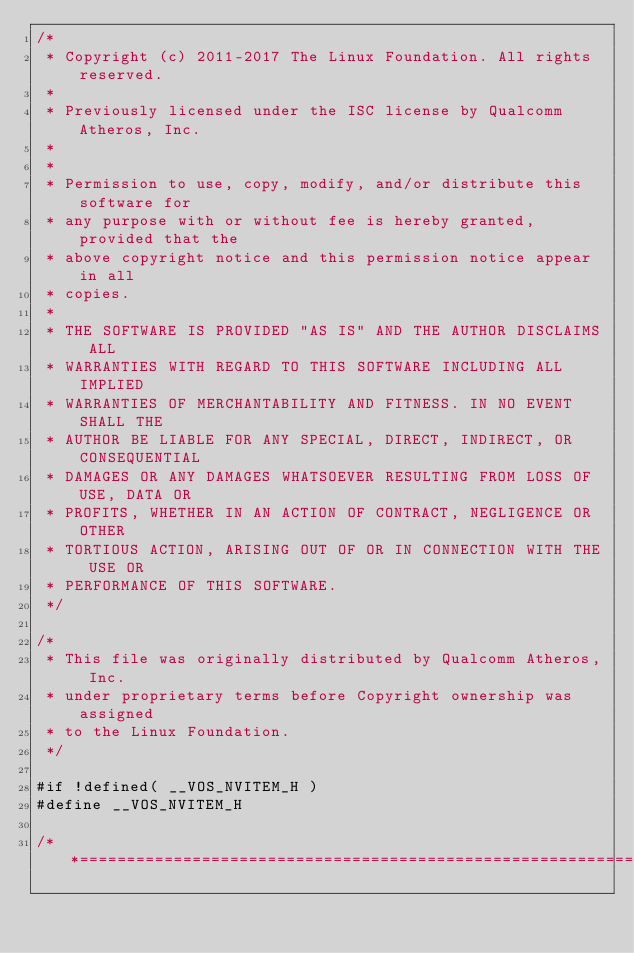<code> <loc_0><loc_0><loc_500><loc_500><_C_>/*
 * Copyright (c) 2011-2017 The Linux Foundation. All rights reserved.
 *
 * Previously licensed under the ISC license by Qualcomm Atheros, Inc.
 *
 *
 * Permission to use, copy, modify, and/or distribute this software for
 * any purpose with or without fee is hereby granted, provided that the
 * above copyright notice and this permission notice appear in all
 * copies.
 *
 * THE SOFTWARE IS PROVIDED "AS IS" AND THE AUTHOR DISCLAIMS ALL
 * WARRANTIES WITH REGARD TO THIS SOFTWARE INCLUDING ALL IMPLIED
 * WARRANTIES OF MERCHANTABILITY AND FITNESS. IN NO EVENT SHALL THE
 * AUTHOR BE LIABLE FOR ANY SPECIAL, DIRECT, INDIRECT, OR CONSEQUENTIAL
 * DAMAGES OR ANY DAMAGES WHATSOEVER RESULTING FROM LOSS OF USE, DATA OR
 * PROFITS, WHETHER IN AN ACTION OF CONTRACT, NEGLIGENCE OR OTHER
 * TORTIOUS ACTION, ARISING OUT OF OR IN CONNECTION WITH THE USE OR
 * PERFORMANCE OF THIS SOFTWARE.
 */

/*
 * This file was originally distributed by Qualcomm Atheros, Inc.
 * under proprietary terms before Copyright ownership was assigned
 * to the Linux Foundation.
 */

#if !defined( __VOS_NVITEM_H )
#define __VOS_NVITEM_H

/**=========================================================================
</code> 